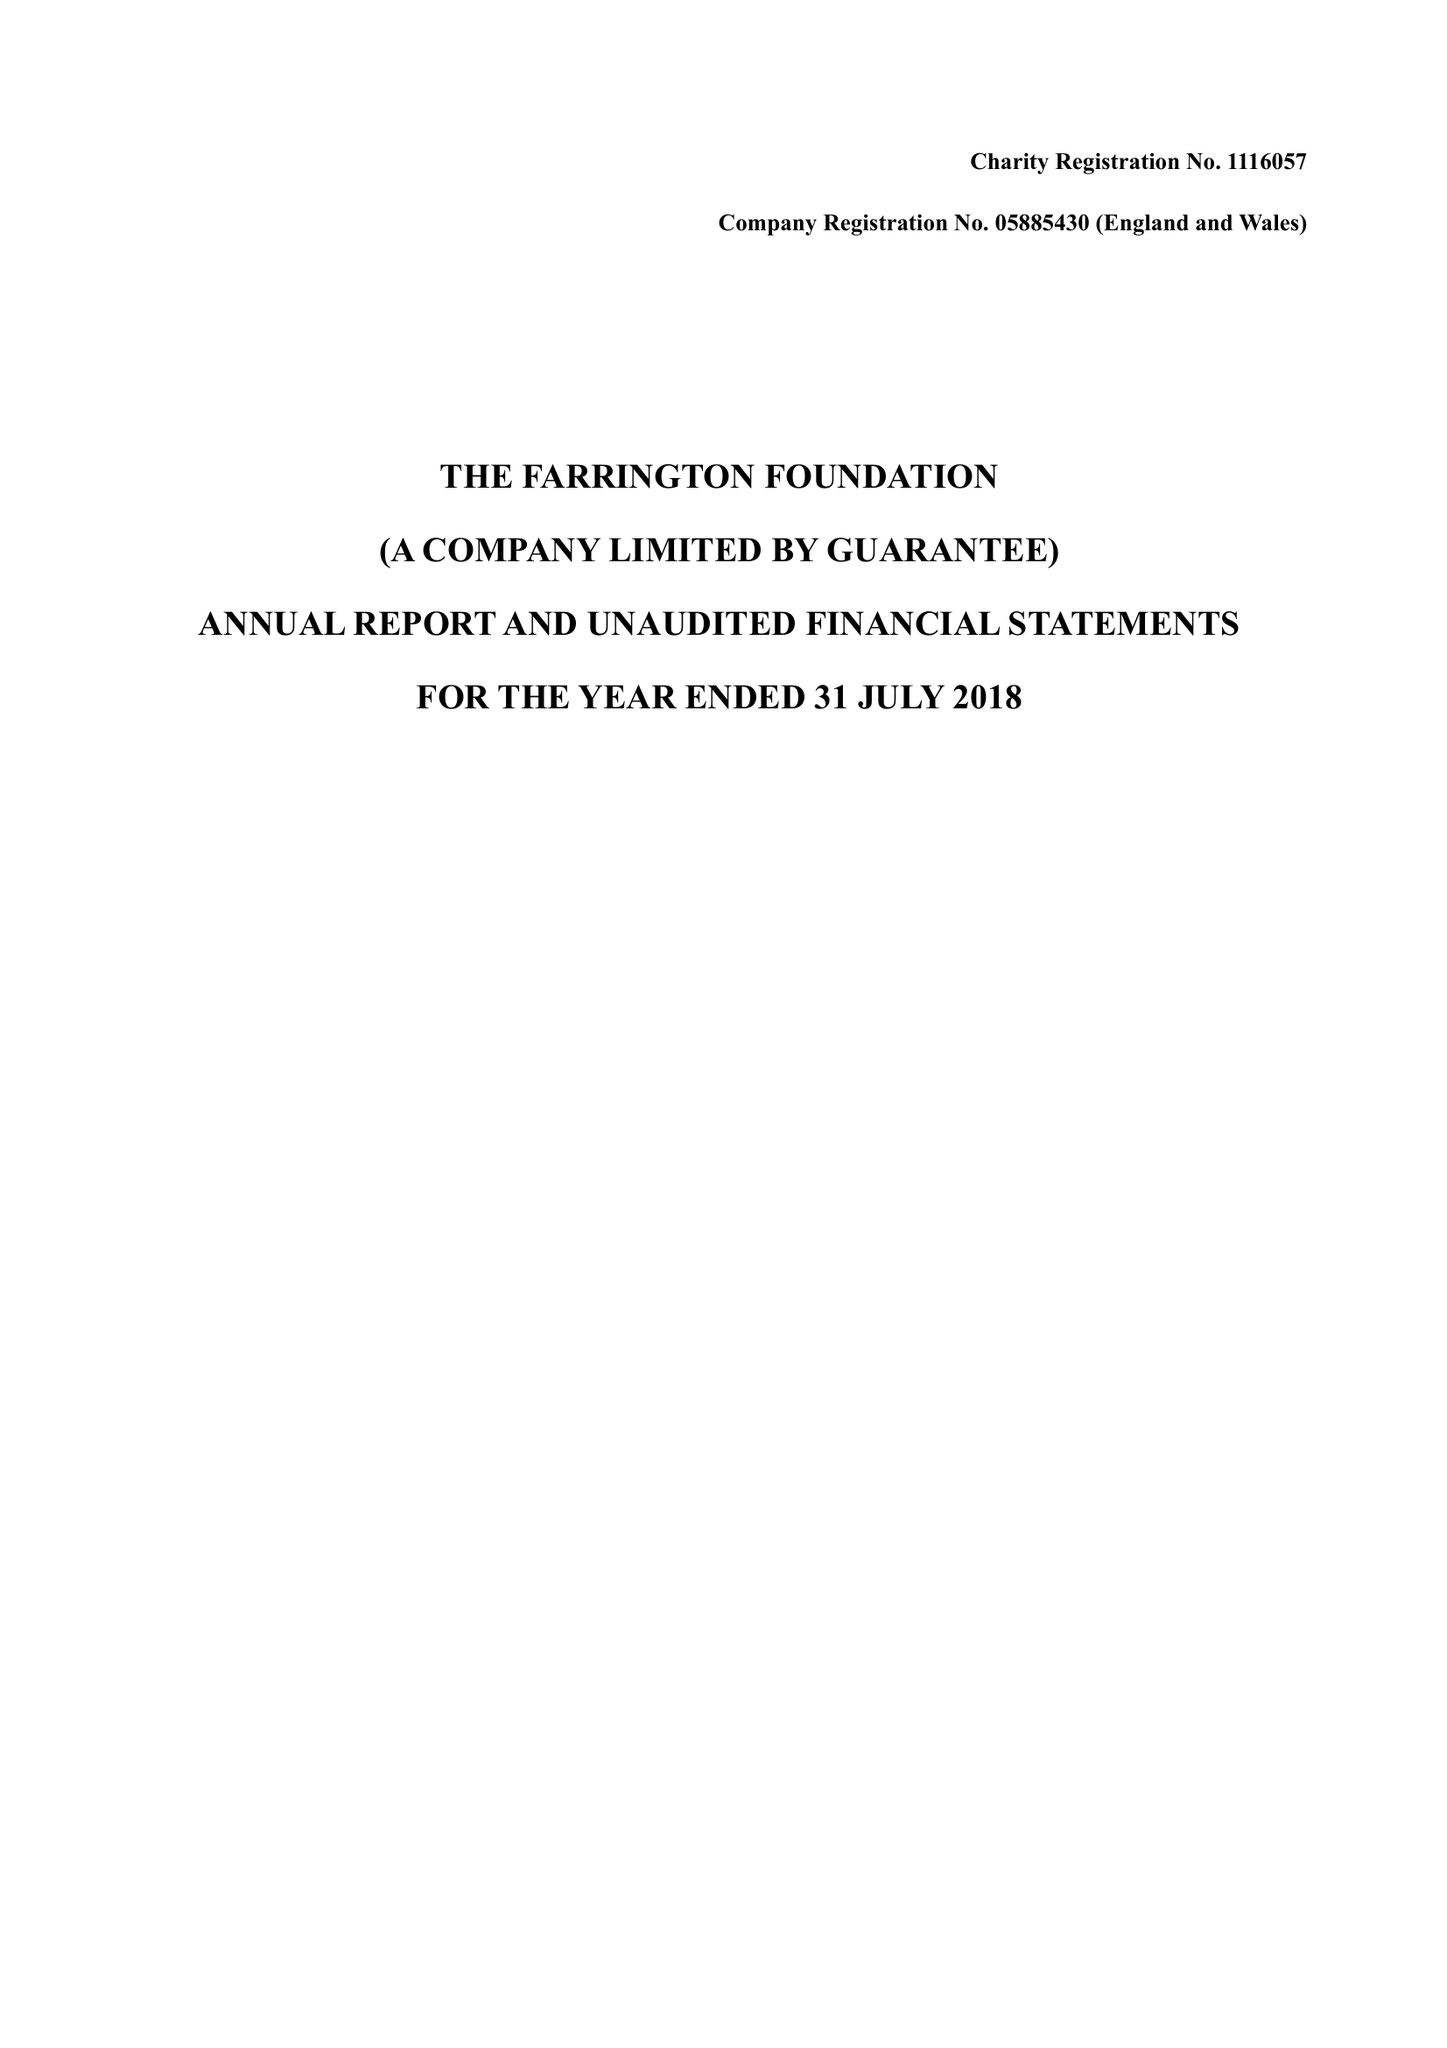What is the value for the address__street_line?
Answer the question using a single word or phrase. 1 FARRINGTON PLACE 